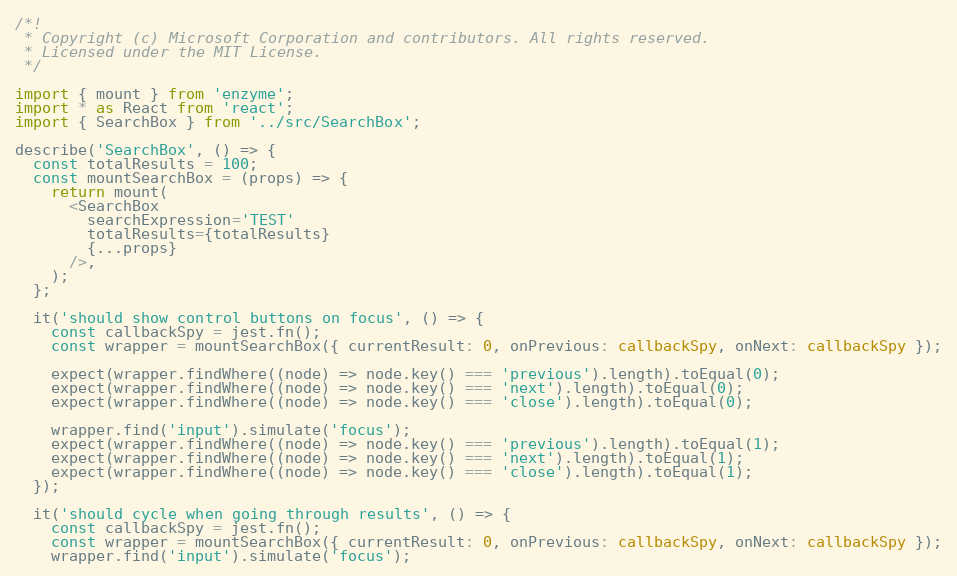Convert code to text. <code><loc_0><loc_0><loc_500><loc_500><_TypeScript_>/*!
 * Copyright (c) Microsoft Corporation and contributors. All rights reserved.
 * Licensed under the MIT License.
 */

import { mount } from 'enzyme';
import * as React from 'react';
import { SearchBox } from '../src/SearchBox';

describe('SearchBox', () => {
  const totalResults = 100;
  const mountSearchBox = (props) => {
    return mount(
      <SearchBox
        searchExpression='TEST'
        totalResults={totalResults}
        {...props}
      />,
    );
  };

  it('should show control buttons on focus', () => {
    const callbackSpy = jest.fn();
    const wrapper = mountSearchBox({ currentResult: 0, onPrevious: callbackSpy, onNext: callbackSpy });

    expect(wrapper.findWhere((node) => node.key() === 'previous').length).toEqual(0);
    expect(wrapper.findWhere((node) => node.key() === 'next').length).toEqual(0);
    expect(wrapper.findWhere((node) => node.key() === 'close').length).toEqual(0);

    wrapper.find('input').simulate('focus');
    expect(wrapper.findWhere((node) => node.key() === 'previous').length).toEqual(1);
    expect(wrapper.findWhere((node) => node.key() === 'next').length).toEqual(1);
    expect(wrapper.findWhere((node) => node.key() === 'close').length).toEqual(1);
  });

  it('should cycle when going through results', () => {
    const callbackSpy = jest.fn();
    const wrapper = mountSearchBox({ currentResult: 0, onPrevious: callbackSpy, onNext: callbackSpy });
    wrapper.find('input').simulate('focus');</code> 